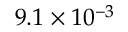<formula> <loc_0><loc_0><loc_500><loc_500>9 . 1 \times 1 0 ^ { - 3 }</formula> 